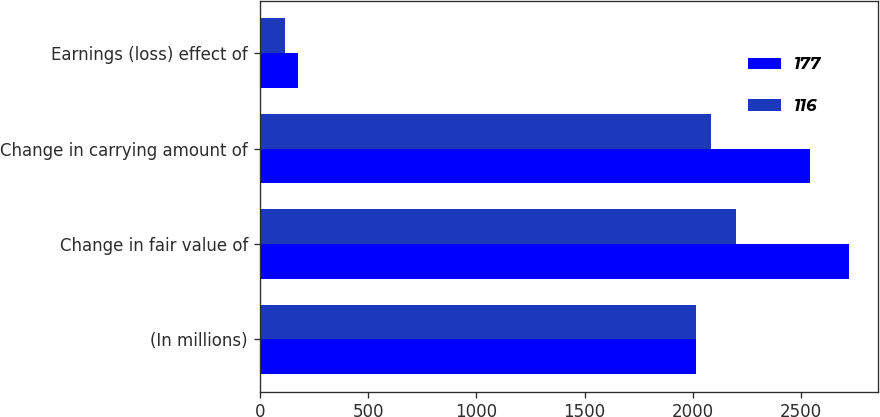Convert chart. <chart><loc_0><loc_0><loc_500><loc_500><stacked_bar_chart><ecel><fcel>(In millions)<fcel>Change in fair value of<fcel>Change in carrying amount of<fcel>Earnings (loss) effect of<nl><fcel>177<fcel>2015<fcel>2720<fcel>2543<fcel>177<nl><fcel>116<fcel>2014<fcel>2198<fcel>2083<fcel>116<nl></chart> 